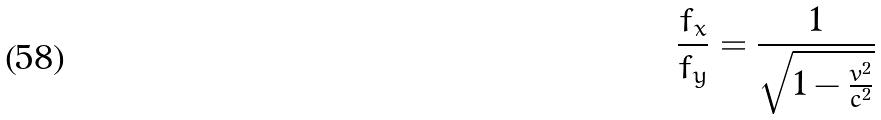<formula> <loc_0><loc_0><loc_500><loc_500>\frac { f _ { x } } { f _ { y } } = \frac { 1 } { \sqrt { 1 - \frac { v ^ { 2 } } { c ^ { 2 } } } }</formula> 